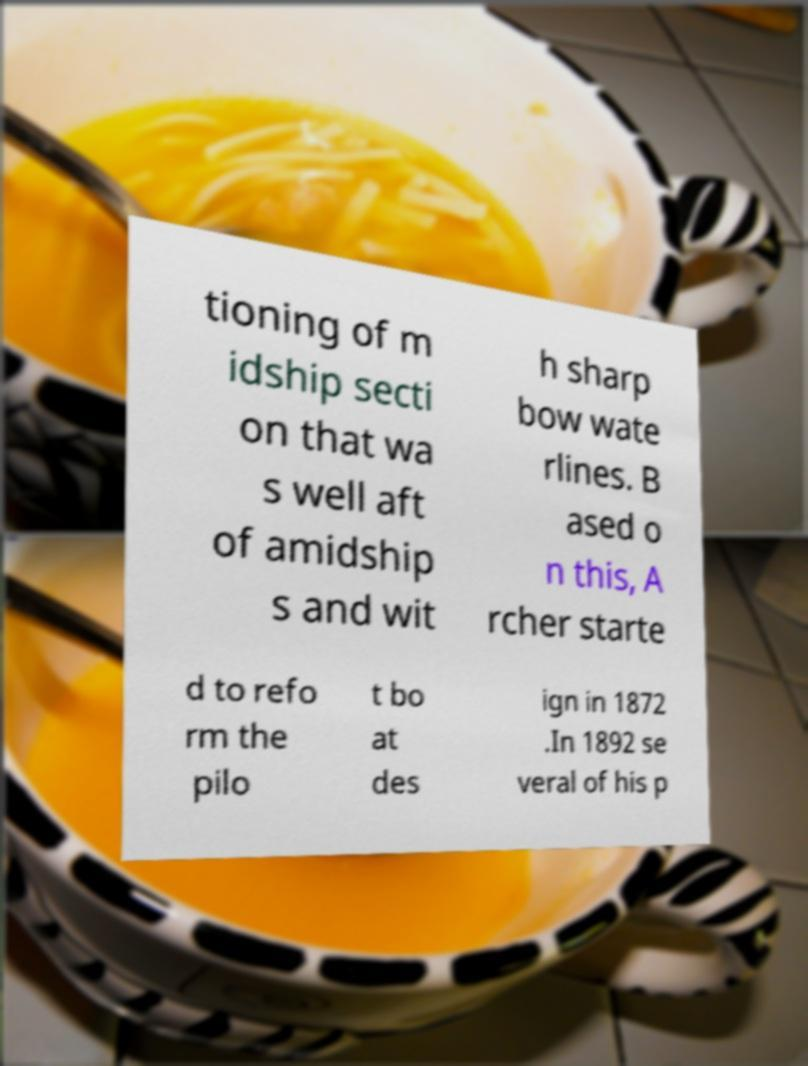For documentation purposes, I need the text within this image transcribed. Could you provide that? tioning of m idship secti on that wa s well aft of amidship s and wit h sharp bow wate rlines. B ased o n this, A rcher starte d to refo rm the pilo t bo at des ign in 1872 .In 1892 se veral of his p 